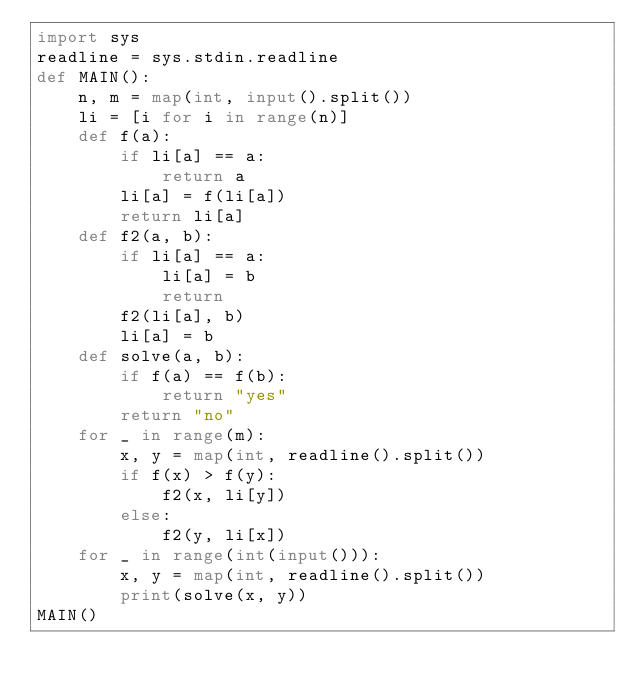<code> <loc_0><loc_0><loc_500><loc_500><_Python_>import sys
readline = sys.stdin.readline
def MAIN():
    n, m = map(int, input().split())
    li = [i for i in range(n)]
    def f(a):
        if li[a] == a:
            return a
        li[a] = f(li[a])
        return li[a]
    def f2(a, b):
        if li[a] == a:
            li[a] = b
            return
        f2(li[a], b)
        li[a] = b
    def solve(a, b):
        if f(a) == f(b):
            return "yes"
        return "no"
    for _ in range(m):
        x, y = map(int, readline().split())
        if f(x) > f(y):
            f2(x, li[y])
        else:
            f2(y, li[x])
    for _ in range(int(input())):
        x, y = map(int, readline().split())
        print(solve(x, y))
MAIN()

</code> 